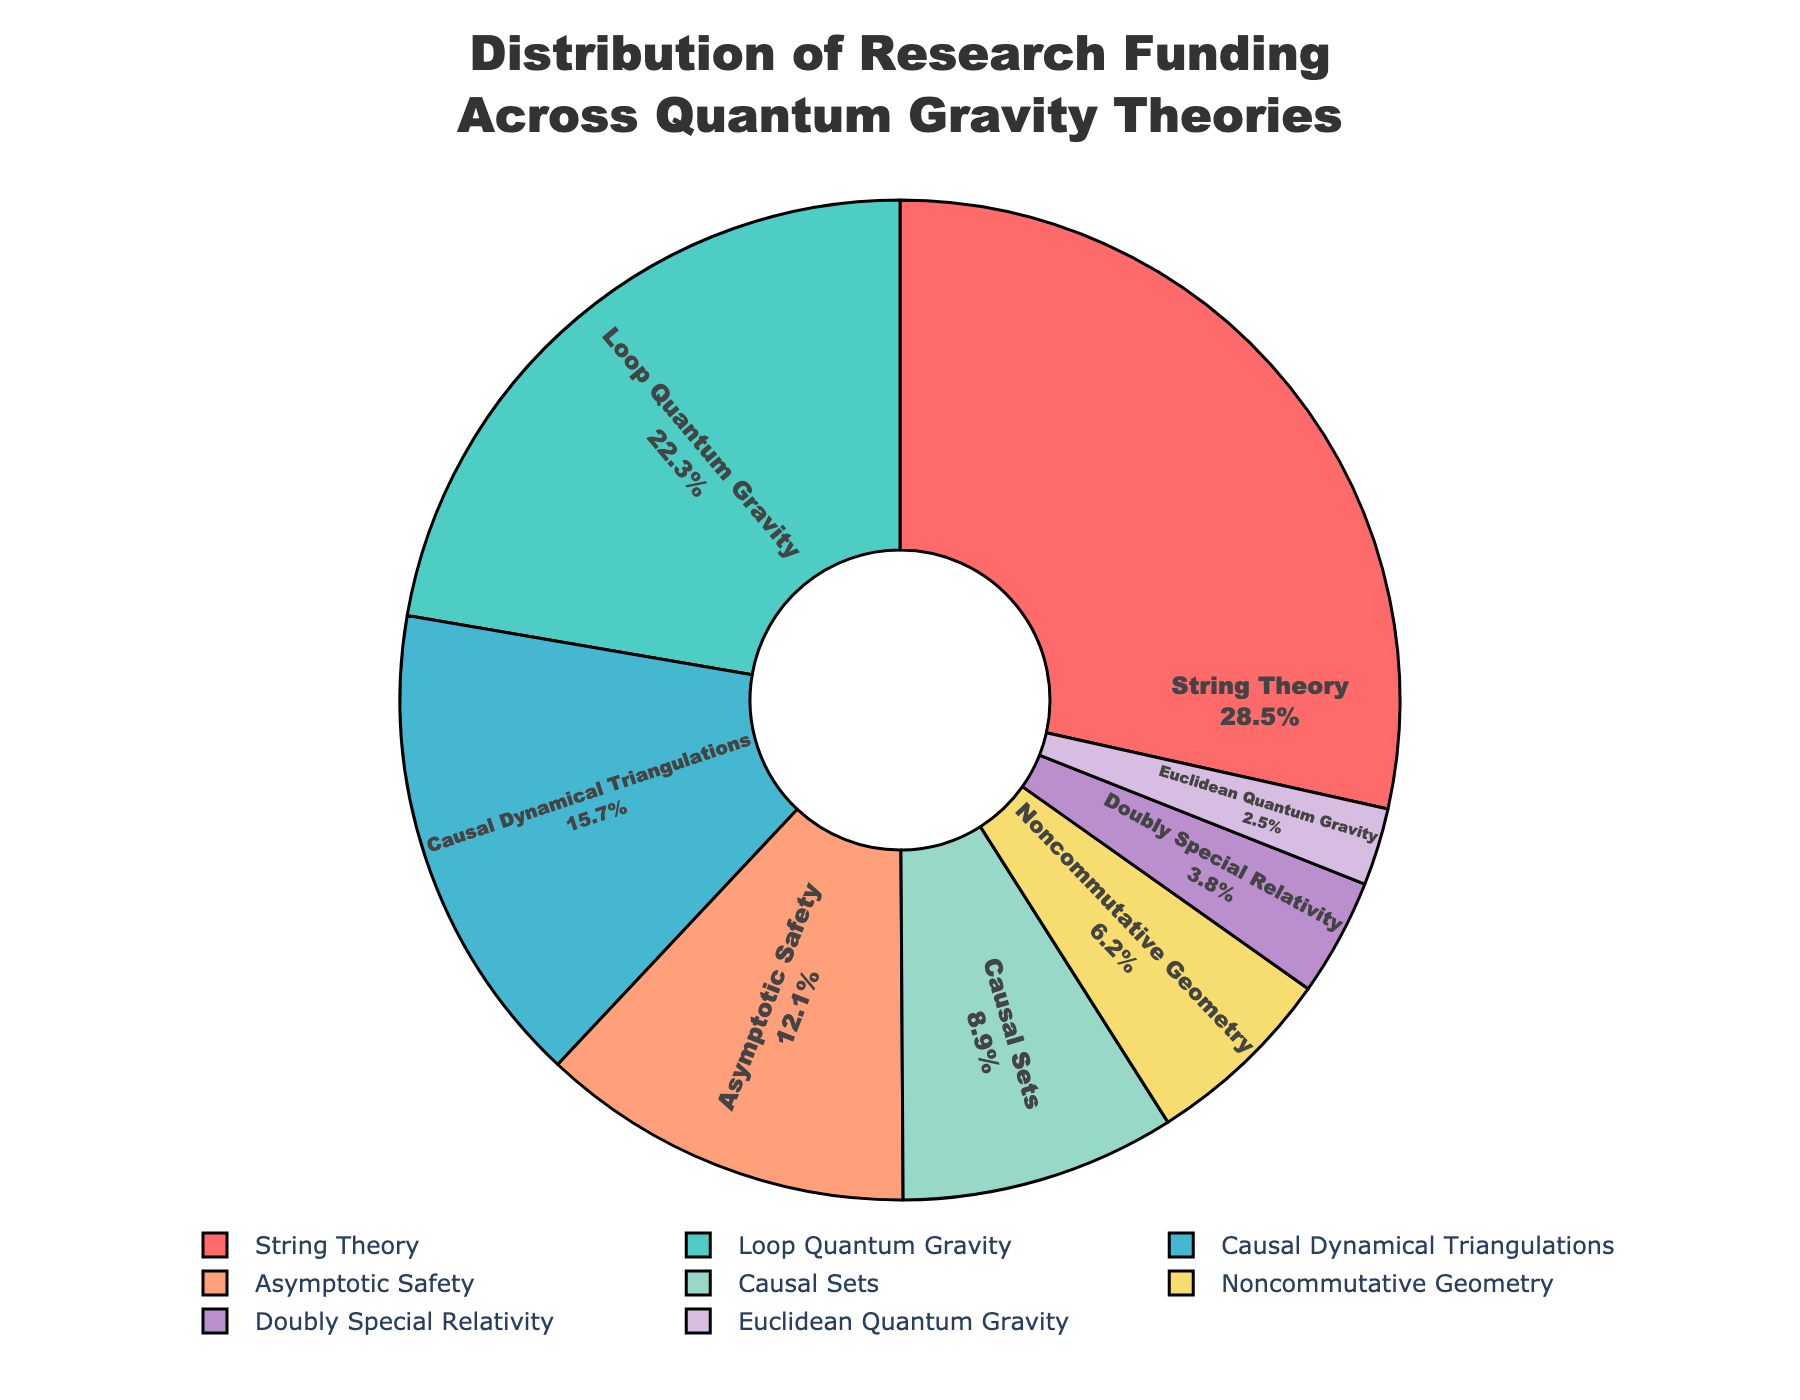What's the largest funding share? The largest segment in the pie chart corresponds to String Theory, which has a funding percentage of 28.5%. You can see this by looking at the size of the segment and confirming with the label.
Answer: 28.5% Which theory has the smallest funding? The smallest segment in the pie chart corresponds to Euclidean Quantum Gravity, which has a funding percentage of 2.5%.
Answer: 2.5% How much more funding does String Theory receive compared to Loop Quantum Gravity? String Theory has a funding percentage of 28.5% and Loop Quantum Gravity has 22.3%. The difference is 28.5% - 22.3% = 6.2%.
Answer: 6.2% What is the total funding for Asymptotic Safety and Causal Sets combined? Asymptotic Safety has a funding percentage of 12.1% and Causal Sets has 8.9%. The combined funding is 12.1% + 8.9% = 21.0%.
Answer: 21.0% How does the funding for Noncommutative Geometry compare to Doubly Special Relativity? Noncommutative Geometry has a funding percentage of 6.2% while Doubly Special Relativity has 3.8%. Therefore, Noncommutative Geometry receives 6.2% - 3.8% = 2.4% more funding.
Answer: 2.4% What is the average funding for the three most-funded theories? The three most-funded theories are String Theory (28.5%), Loop Quantum Gravity (22.3%), and Causal Dynamical Triangulations (15.7%). The average funding is (28.5% + 22.3% + 15.7%) / 3 = 22.17%.
Answer: 22.17% Which theories together constitute about half of the total funding? String Theory and Loop Quantum Gravity together make up the largest percentages. Their combined funding is 28.5% + 22.3% = 50.8%, which is approximately half of the total funding.
Answer: String Theory and Loop Quantum Gravity What color represents Causal Sets? The color corresponding to Causal Sets in the pie chart is a light yellow shade. You can identify this by cross-referencing the labels with the visual segments of the pie chart.
Answer: Yellow Which funding category is represented by the purple segment of the pie chart? The purple segment of the pie chart represents Noncommutative Geometry.
Answer: Noncommutative Geometry How much more funding does Causal Dynamical Triangulations receive than Euclidean Quantum Gravity? Causal Dynamical Triangulations receives 15.7% while Euclidean Quantum Gravity receives 2.5%. The difference is 15.7% - 2.5% = 13.2%.
Answer: 13.2% 